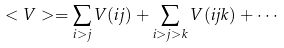Convert formula to latex. <formula><loc_0><loc_0><loc_500><loc_500>< V > = \sum _ { i > j } V ( i j ) + \sum _ { i > j > k } V ( i j k ) + \cdots</formula> 